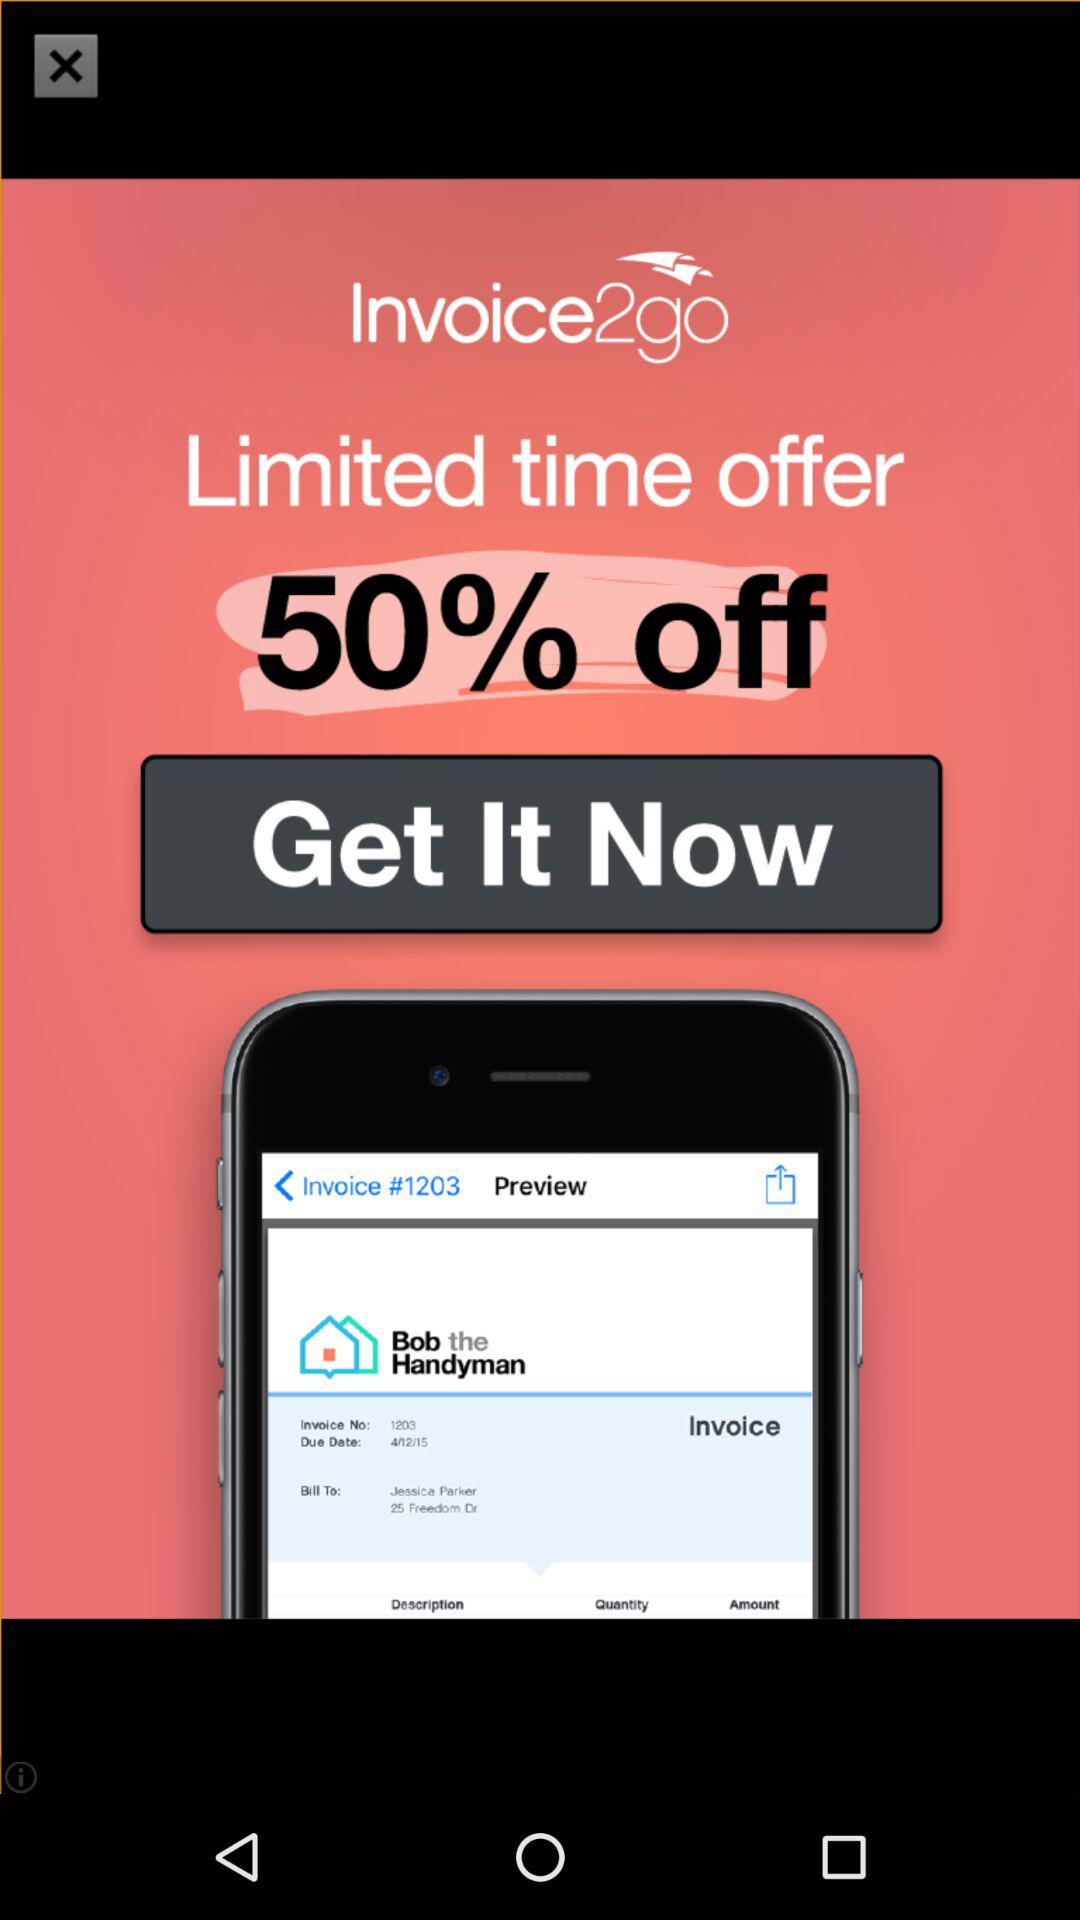What is the name of the application? The name of the application is "Invoice2go". 